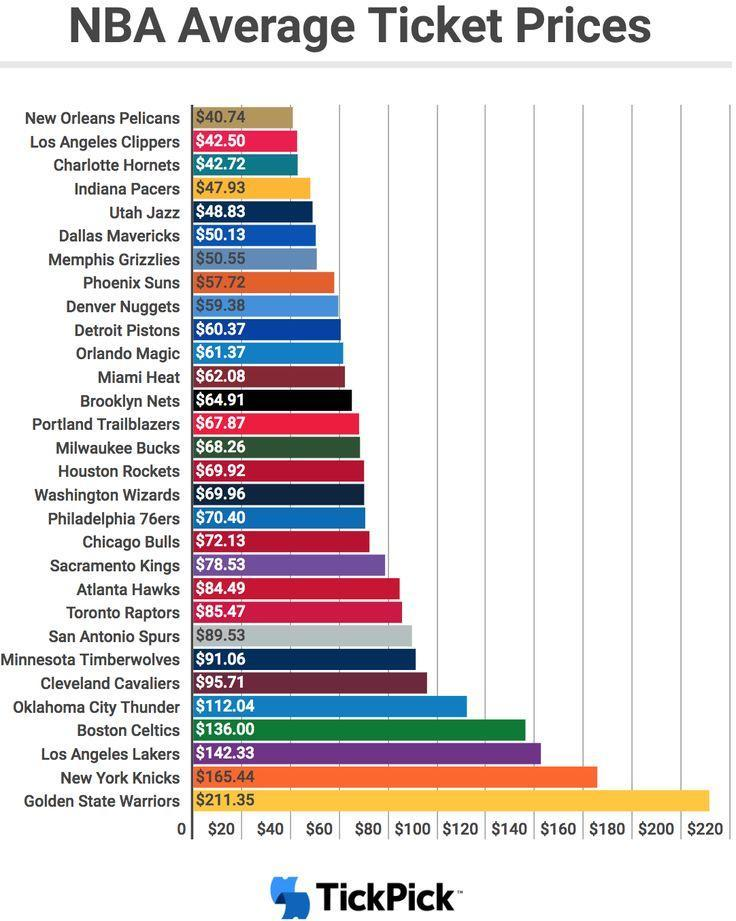What is the total ticket rate in $ for Detroit Pistons and Orlando Magic
Answer the question with a short phrase. 121.74 How much more the ticket rate of New York Knicks that when compared to Boston Ceiltics 29.44 